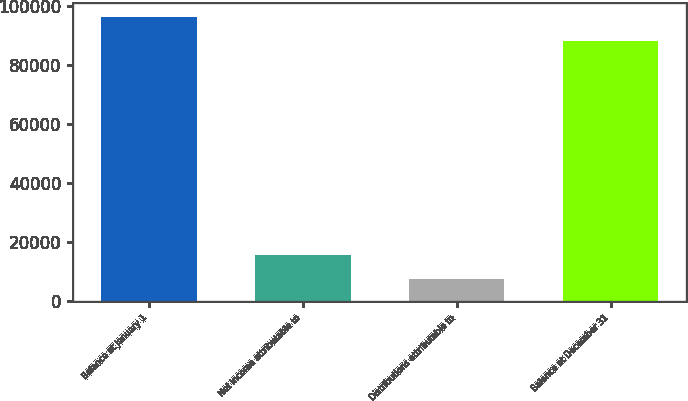Convert chart. <chart><loc_0><loc_0><loc_500><loc_500><bar_chart><fcel>Balance at January 1<fcel>Net income attributable to<fcel>Distributions attributable to<fcel>Balance at December 31<nl><fcel>96371<fcel>15709<fcel>7486<fcel>88148<nl></chart> 